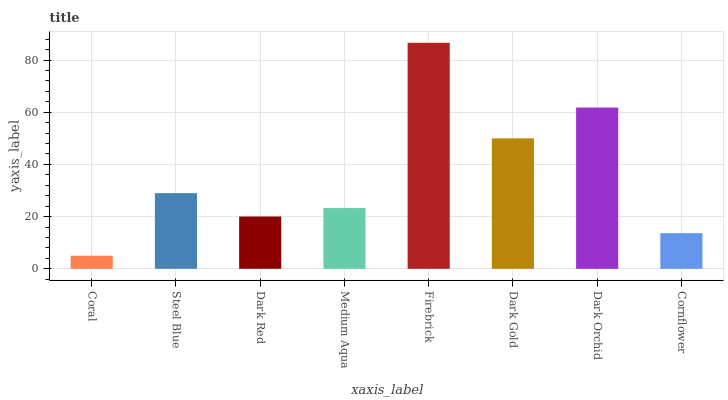Is Coral the minimum?
Answer yes or no. Yes. Is Firebrick the maximum?
Answer yes or no. Yes. Is Steel Blue the minimum?
Answer yes or no. No. Is Steel Blue the maximum?
Answer yes or no. No. Is Steel Blue greater than Coral?
Answer yes or no. Yes. Is Coral less than Steel Blue?
Answer yes or no. Yes. Is Coral greater than Steel Blue?
Answer yes or no. No. Is Steel Blue less than Coral?
Answer yes or no. No. Is Steel Blue the high median?
Answer yes or no. Yes. Is Medium Aqua the low median?
Answer yes or no. Yes. Is Dark Orchid the high median?
Answer yes or no. No. Is Steel Blue the low median?
Answer yes or no. No. 